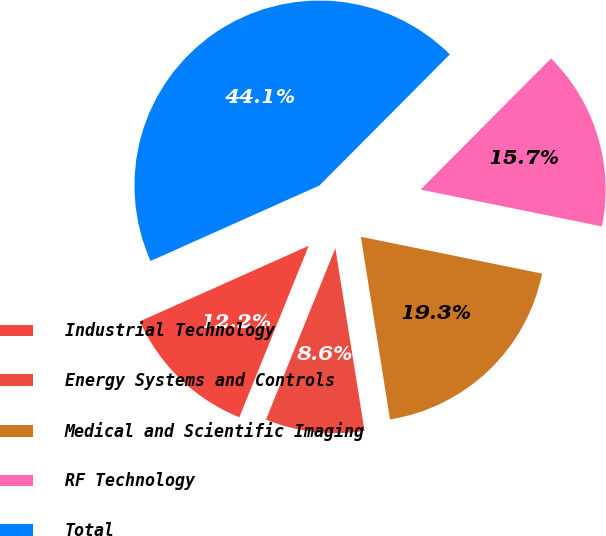Convert chart. <chart><loc_0><loc_0><loc_500><loc_500><pie_chart><fcel>Industrial Technology<fcel>Energy Systems and Controls<fcel>Medical and Scientific Imaging<fcel>RF Technology<fcel>Total<nl><fcel>12.19%<fcel>8.64%<fcel>19.29%<fcel>15.74%<fcel>44.15%<nl></chart> 